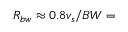<formula> <loc_0><loc_0><loc_500><loc_500>R _ { b w } \approx 0 . 8 v _ { s } / B W =</formula> 